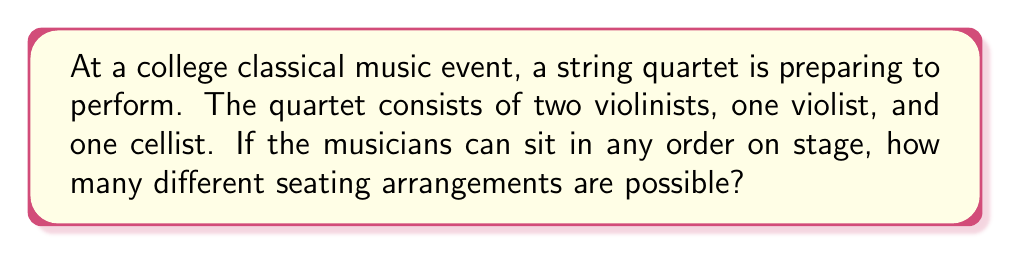Solve this math problem. Let's approach this step-by-step:

1) First, we need to recognize that this is a permutation problem. We are arranging all 4 musicians in different orders.

2) In a permutation where all elements are distinct, the number of arrangements would be calculated as:

   $$ P(4,4) = 4! = 4 \times 3 \times 2 \times 1 = 24 $$

3) However, we need to consider that there are two violinists. If we swap the positions of these two violinists, it doesn't create a new arrangement from the audience's perspective.

4) To account for this, we need to divide our total number of permutations by the number of ways to arrange the violinists among themselves, which is 2! (2 factorial).

5) Therefore, the final calculation is:

   $$ \frac{4!}{2!} = \frac{24}{2} = 12 $$

This gives us the total number of distinct seating arrangements for the string quartet.
Answer: 12 possible seating arrangements 